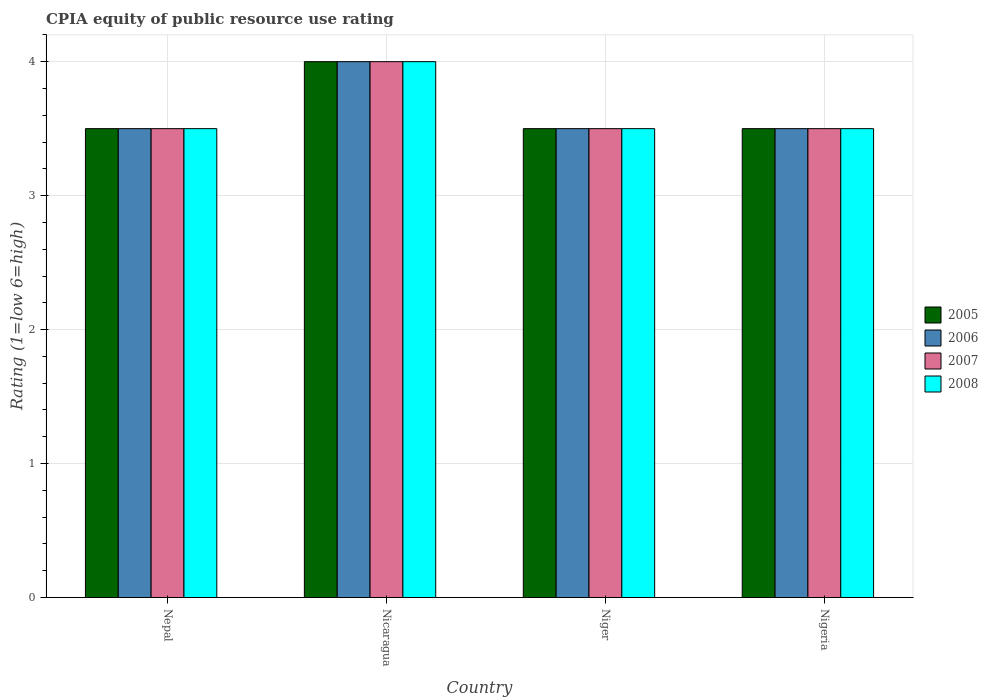Are the number of bars per tick equal to the number of legend labels?
Provide a succinct answer. Yes. How many bars are there on the 4th tick from the right?
Provide a succinct answer. 4. What is the label of the 3rd group of bars from the left?
Your answer should be compact. Niger. Across all countries, what is the maximum CPIA rating in 2005?
Make the answer very short. 4. In which country was the CPIA rating in 2007 maximum?
Keep it short and to the point. Nicaragua. In which country was the CPIA rating in 2007 minimum?
Provide a short and direct response. Nepal. What is the total CPIA rating in 2007 in the graph?
Offer a very short reply. 14.5. What is the difference between the CPIA rating in 2005 in Nepal and that in Niger?
Provide a short and direct response. 0. What is the difference between the CPIA rating in 2005 in Nepal and the CPIA rating in 2006 in Nicaragua?
Your response must be concise. -0.5. What is the average CPIA rating in 2008 per country?
Give a very brief answer. 3.62. In how many countries, is the CPIA rating in 2006 greater than 1.6?
Keep it short and to the point. 4. What is the ratio of the CPIA rating in 2007 in Nepal to that in Nicaragua?
Your response must be concise. 0.88. What is the difference between the highest and the second highest CPIA rating in 2006?
Keep it short and to the point. -0.5. In how many countries, is the CPIA rating in 2006 greater than the average CPIA rating in 2006 taken over all countries?
Ensure brevity in your answer.  1. Is it the case that in every country, the sum of the CPIA rating in 2005 and CPIA rating in 2006 is greater than the sum of CPIA rating in 2007 and CPIA rating in 2008?
Give a very brief answer. No. Is it the case that in every country, the sum of the CPIA rating in 2007 and CPIA rating in 2005 is greater than the CPIA rating in 2006?
Provide a short and direct response. Yes. How many countries are there in the graph?
Your answer should be very brief. 4. Are the values on the major ticks of Y-axis written in scientific E-notation?
Make the answer very short. No. Does the graph contain any zero values?
Your answer should be very brief. No. Does the graph contain grids?
Your answer should be very brief. Yes. Where does the legend appear in the graph?
Provide a short and direct response. Center right. How many legend labels are there?
Ensure brevity in your answer.  4. What is the title of the graph?
Offer a very short reply. CPIA equity of public resource use rating. What is the label or title of the X-axis?
Ensure brevity in your answer.  Country. What is the label or title of the Y-axis?
Your answer should be compact. Rating (1=low 6=high). What is the Rating (1=low 6=high) of 2006 in Nepal?
Offer a terse response. 3.5. What is the Rating (1=low 6=high) of 2007 in Nicaragua?
Give a very brief answer. 4. What is the Rating (1=low 6=high) in 2008 in Nicaragua?
Provide a short and direct response. 4. What is the Rating (1=low 6=high) of 2006 in Niger?
Your response must be concise. 3.5. What is the Rating (1=low 6=high) of 2008 in Niger?
Offer a very short reply. 3.5. What is the Rating (1=low 6=high) of 2005 in Nigeria?
Give a very brief answer. 3.5. What is the Rating (1=low 6=high) in 2006 in Nigeria?
Give a very brief answer. 3.5. What is the Rating (1=low 6=high) of 2007 in Nigeria?
Give a very brief answer. 3.5. Across all countries, what is the maximum Rating (1=low 6=high) of 2006?
Your response must be concise. 4. Across all countries, what is the maximum Rating (1=low 6=high) of 2008?
Provide a short and direct response. 4. Across all countries, what is the minimum Rating (1=low 6=high) in 2005?
Give a very brief answer. 3.5. Across all countries, what is the minimum Rating (1=low 6=high) in 2006?
Ensure brevity in your answer.  3.5. What is the total Rating (1=low 6=high) of 2008 in the graph?
Your answer should be compact. 14.5. What is the difference between the Rating (1=low 6=high) of 2007 in Nepal and that in Nicaragua?
Ensure brevity in your answer.  -0.5. What is the difference between the Rating (1=low 6=high) of 2008 in Nepal and that in Nicaragua?
Offer a terse response. -0.5. What is the difference between the Rating (1=low 6=high) of 2006 in Nepal and that in Niger?
Offer a very short reply. 0. What is the difference between the Rating (1=low 6=high) of 2008 in Nepal and that in Niger?
Ensure brevity in your answer.  0. What is the difference between the Rating (1=low 6=high) of 2005 in Nepal and that in Nigeria?
Provide a short and direct response. 0. What is the difference between the Rating (1=low 6=high) of 2006 in Nepal and that in Nigeria?
Provide a succinct answer. 0. What is the difference between the Rating (1=low 6=high) in 2008 in Nepal and that in Nigeria?
Give a very brief answer. 0. What is the difference between the Rating (1=low 6=high) in 2005 in Nicaragua and that in Niger?
Ensure brevity in your answer.  0.5. What is the difference between the Rating (1=low 6=high) of 2006 in Nicaragua and that in Niger?
Make the answer very short. 0.5. What is the difference between the Rating (1=low 6=high) in 2006 in Nicaragua and that in Nigeria?
Offer a terse response. 0.5. What is the difference between the Rating (1=low 6=high) in 2007 in Nicaragua and that in Nigeria?
Provide a succinct answer. 0.5. What is the difference between the Rating (1=low 6=high) of 2005 in Niger and that in Nigeria?
Offer a terse response. 0. What is the difference between the Rating (1=low 6=high) of 2008 in Niger and that in Nigeria?
Make the answer very short. 0. What is the difference between the Rating (1=low 6=high) in 2005 in Nepal and the Rating (1=low 6=high) in 2007 in Nicaragua?
Ensure brevity in your answer.  -0.5. What is the difference between the Rating (1=low 6=high) in 2006 in Nepal and the Rating (1=low 6=high) in 2007 in Nicaragua?
Offer a very short reply. -0.5. What is the difference between the Rating (1=low 6=high) in 2006 in Nepal and the Rating (1=low 6=high) in 2008 in Nicaragua?
Ensure brevity in your answer.  -0.5. What is the difference between the Rating (1=low 6=high) of 2005 in Nepal and the Rating (1=low 6=high) of 2006 in Niger?
Ensure brevity in your answer.  0. What is the difference between the Rating (1=low 6=high) of 2005 in Nepal and the Rating (1=low 6=high) of 2007 in Niger?
Your response must be concise. 0. What is the difference between the Rating (1=low 6=high) in 2006 in Nepal and the Rating (1=low 6=high) in 2008 in Niger?
Make the answer very short. 0. What is the difference between the Rating (1=low 6=high) in 2005 in Nepal and the Rating (1=low 6=high) in 2006 in Nigeria?
Your answer should be very brief. 0. What is the difference between the Rating (1=low 6=high) of 2005 in Nepal and the Rating (1=low 6=high) of 2007 in Nigeria?
Provide a short and direct response. 0. What is the difference between the Rating (1=low 6=high) in 2005 in Nepal and the Rating (1=low 6=high) in 2008 in Nigeria?
Ensure brevity in your answer.  0. What is the difference between the Rating (1=low 6=high) of 2007 in Nicaragua and the Rating (1=low 6=high) of 2008 in Niger?
Your answer should be compact. 0.5. What is the difference between the Rating (1=low 6=high) of 2005 in Nicaragua and the Rating (1=low 6=high) of 2006 in Nigeria?
Your answer should be compact. 0.5. What is the difference between the Rating (1=low 6=high) in 2005 in Nicaragua and the Rating (1=low 6=high) in 2007 in Nigeria?
Ensure brevity in your answer.  0.5. What is the difference between the Rating (1=low 6=high) in 2006 in Nicaragua and the Rating (1=low 6=high) in 2007 in Nigeria?
Offer a very short reply. 0.5. What is the difference between the Rating (1=low 6=high) in 2006 in Nicaragua and the Rating (1=low 6=high) in 2008 in Nigeria?
Provide a succinct answer. 0.5. What is the difference between the Rating (1=low 6=high) of 2005 in Niger and the Rating (1=low 6=high) of 2006 in Nigeria?
Your response must be concise. 0. What is the difference between the Rating (1=low 6=high) of 2007 in Niger and the Rating (1=low 6=high) of 2008 in Nigeria?
Provide a short and direct response. 0. What is the average Rating (1=low 6=high) of 2005 per country?
Your response must be concise. 3.62. What is the average Rating (1=low 6=high) of 2006 per country?
Your answer should be compact. 3.62. What is the average Rating (1=low 6=high) of 2007 per country?
Provide a succinct answer. 3.62. What is the average Rating (1=low 6=high) in 2008 per country?
Provide a short and direct response. 3.62. What is the difference between the Rating (1=low 6=high) in 2006 and Rating (1=low 6=high) in 2008 in Nepal?
Your response must be concise. 0. What is the difference between the Rating (1=low 6=high) of 2007 and Rating (1=low 6=high) of 2008 in Nepal?
Your answer should be very brief. 0. What is the difference between the Rating (1=low 6=high) of 2005 and Rating (1=low 6=high) of 2006 in Nicaragua?
Your response must be concise. 0. What is the difference between the Rating (1=low 6=high) of 2005 and Rating (1=low 6=high) of 2007 in Nicaragua?
Your answer should be compact. 0. What is the difference between the Rating (1=low 6=high) of 2006 and Rating (1=low 6=high) of 2008 in Nicaragua?
Your response must be concise. 0. What is the difference between the Rating (1=low 6=high) of 2007 and Rating (1=low 6=high) of 2008 in Nicaragua?
Give a very brief answer. 0. What is the difference between the Rating (1=low 6=high) of 2005 and Rating (1=low 6=high) of 2007 in Niger?
Provide a succinct answer. 0. What is the difference between the Rating (1=low 6=high) in 2005 and Rating (1=low 6=high) in 2008 in Niger?
Provide a succinct answer. 0. What is the difference between the Rating (1=low 6=high) in 2006 and Rating (1=low 6=high) in 2008 in Niger?
Provide a short and direct response. 0. What is the difference between the Rating (1=low 6=high) in 2005 and Rating (1=low 6=high) in 2006 in Nigeria?
Your answer should be very brief. 0. What is the difference between the Rating (1=low 6=high) in 2005 and Rating (1=low 6=high) in 2007 in Nigeria?
Give a very brief answer. 0. What is the ratio of the Rating (1=low 6=high) of 2007 in Nepal to that in Nicaragua?
Provide a short and direct response. 0.88. What is the ratio of the Rating (1=low 6=high) in 2005 in Nepal to that in Niger?
Your answer should be compact. 1. What is the ratio of the Rating (1=low 6=high) of 2006 in Nepal to that in Niger?
Ensure brevity in your answer.  1. What is the ratio of the Rating (1=low 6=high) in 2007 in Nepal to that in Niger?
Your response must be concise. 1. What is the ratio of the Rating (1=low 6=high) in 2008 in Nepal to that in Niger?
Offer a very short reply. 1. What is the ratio of the Rating (1=low 6=high) of 2005 in Nepal to that in Nigeria?
Your answer should be compact. 1. What is the ratio of the Rating (1=low 6=high) of 2007 in Nepal to that in Nigeria?
Your answer should be compact. 1. What is the ratio of the Rating (1=low 6=high) in 2008 in Nepal to that in Nigeria?
Provide a short and direct response. 1. What is the ratio of the Rating (1=low 6=high) of 2006 in Nicaragua to that in Niger?
Your answer should be very brief. 1.14. What is the ratio of the Rating (1=low 6=high) in 2005 in Nicaragua to that in Nigeria?
Your answer should be compact. 1.14. What is the ratio of the Rating (1=low 6=high) of 2006 in Nicaragua to that in Nigeria?
Your response must be concise. 1.14. What is the ratio of the Rating (1=low 6=high) of 2006 in Niger to that in Nigeria?
Ensure brevity in your answer.  1. What is the ratio of the Rating (1=low 6=high) in 2008 in Niger to that in Nigeria?
Your answer should be very brief. 1. What is the difference between the highest and the second highest Rating (1=low 6=high) in 2005?
Offer a very short reply. 0.5. What is the difference between the highest and the second highest Rating (1=low 6=high) in 2006?
Provide a short and direct response. 0.5. What is the difference between the highest and the second highest Rating (1=low 6=high) in 2007?
Give a very brief answer. 0.5. What is the difference between the highest and the second highest Rating (1=low 6=high) in 2008?
Offer a very short reply. 0.5. What is the difference between the highest and the lowest Rating (1=low 6=high) in 2006?
Offer a terse response. 0.5. What is the difference between the highest and the lowest Rating (1=low 6=high) of 2008?
Provide a succinct answer. 0.5. 